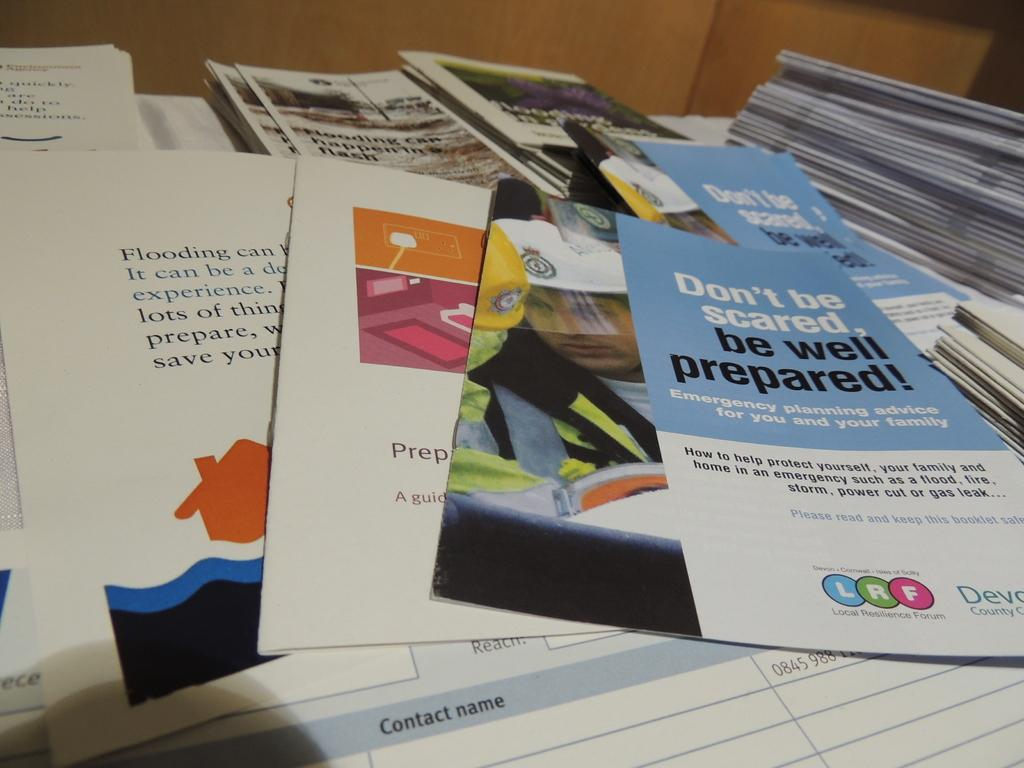<image>
Describe the image concisely. The brochure's title is "Don't be scared, be well prepared!" 